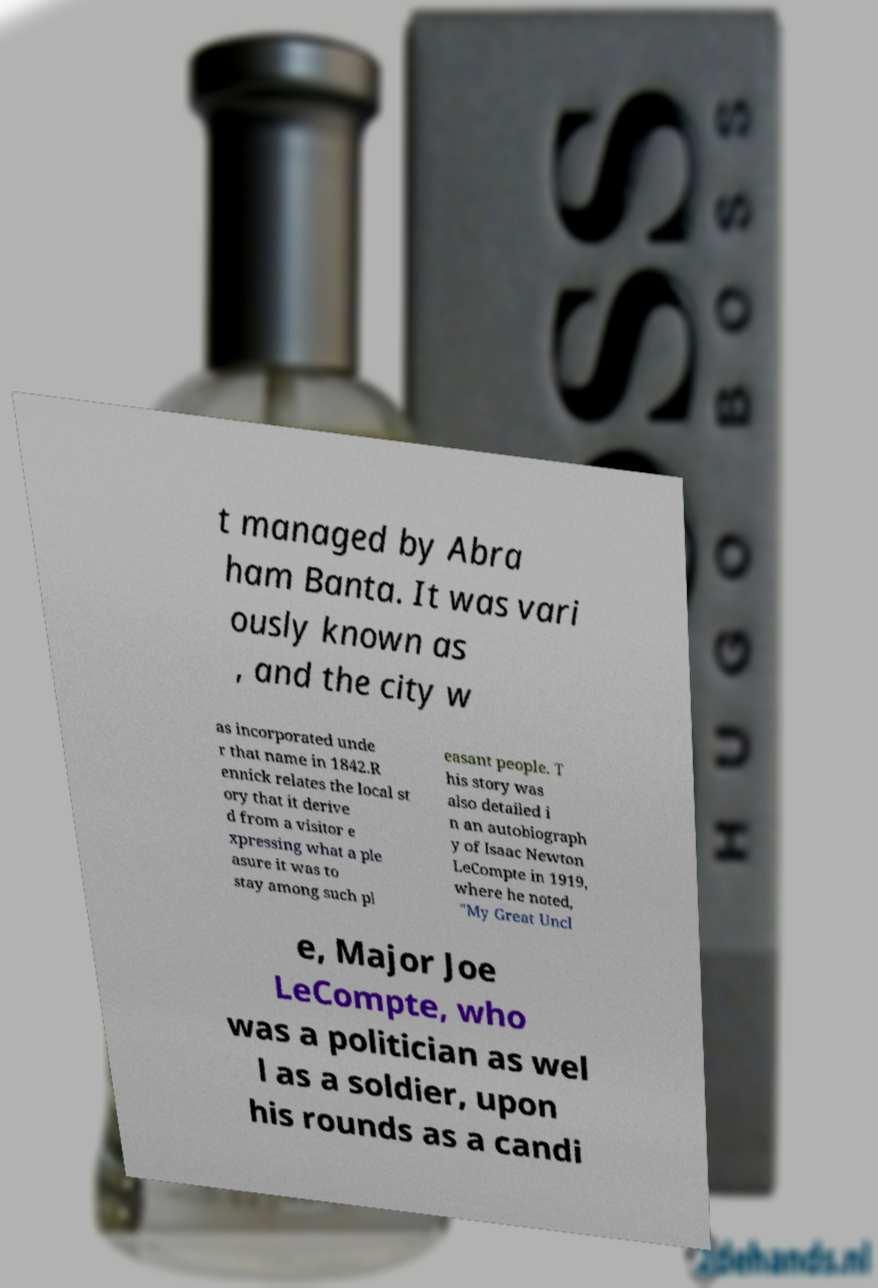For documentation purposes, I need the text within this image transcribed. Could you provide that? t managed by Abra ham Banta. It was vari ously known as , and the city w as incorporated unde r that name in 1842.R ennick relates the local st ory that it derive d from a visitor e xpressing what a ple asure it was to stay among such pl easant people. T his story was also detailed i n an autobiograph y of Isaac Newton LeCompte in 1919, where he noted, "My Great Uncl e, Major Joe LeCompte, who was a politician as wel l as a soldier, upon his rounds as a candi 